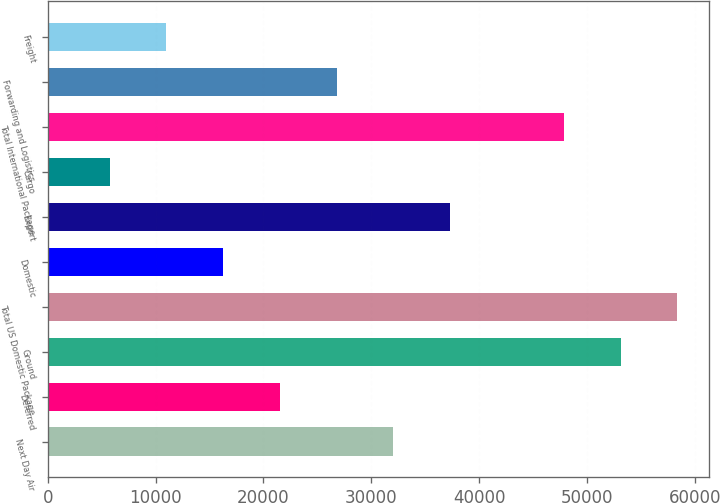Convert chart. <chart><loc_0><loc_0><loc_500><loc_500><bar_chart><fcel>Next Day Air<fcel>Deferred<fcel>Ground<fcel>Total US Domestic Package<fcel>Domestic<fcel>Export<fcel>Cargo<fcel>Total International Package<fcel>Forwarding and Logistics<fcel>Freight<nl><fcel>32052.2<fcel>21525.8<fcel>53105<fcel>58368.2<fcel>16262.6<fcel>37315.4<fcel>5736.2<fcel>47841.8<fcel>26789<fcel>10999.4<nl></chart> 